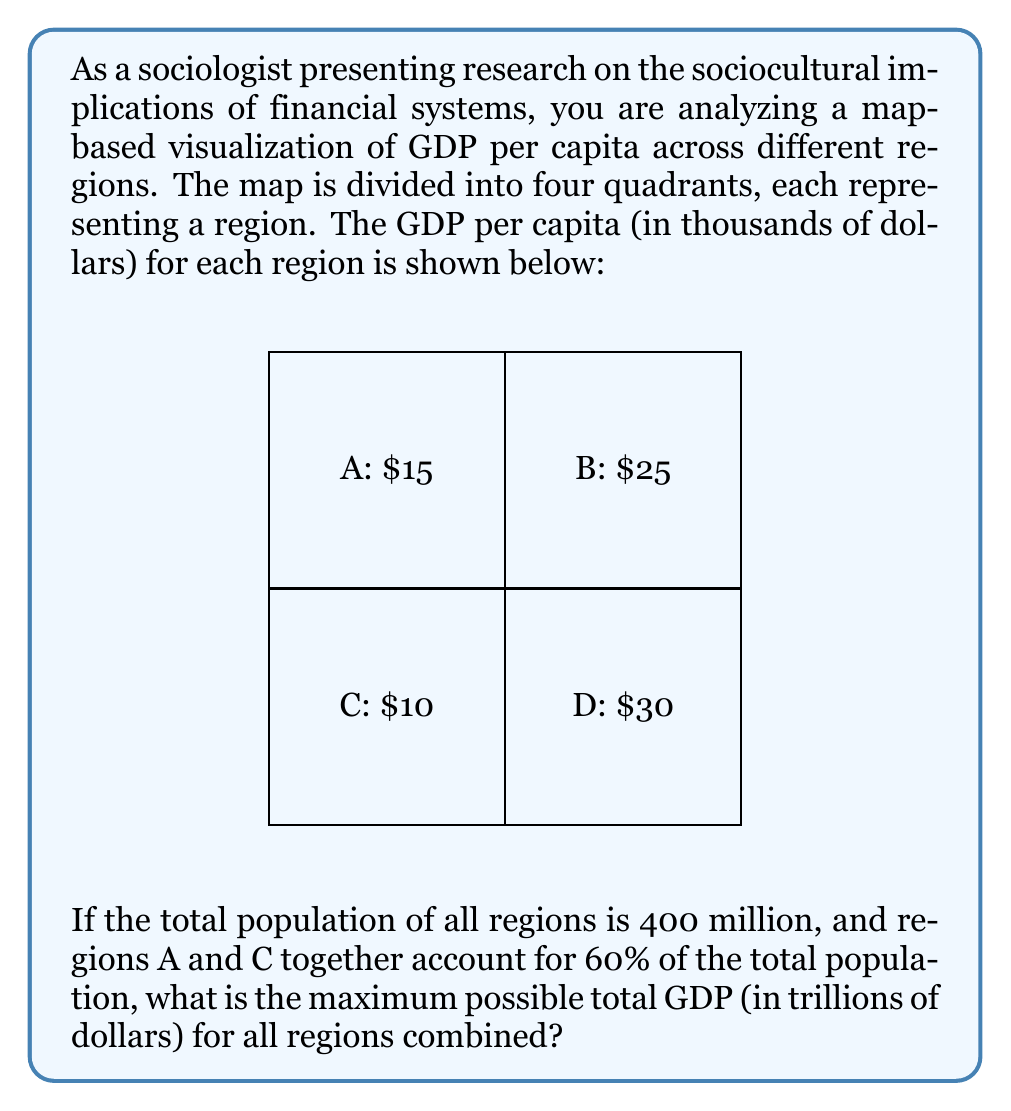Solve this math problem. Let's approach this step-by-step:

1) First, we need to understand what we know:
   - Total population: 400 million
   - Regions A and C together: 60% of total population = 0.6 × 400 million = 240 million
   - GDP per capita for each region (in thousands of dollars): A: $15, B: $25, C: $10, D: $30

2) To maximize the total GDP, we should allocate as much population as possible to the regions with higher GDP per capita.

3) Regions B and D have higher GDP per capita, so we should allocate the remaining 40% of the population to these regions:
   40% of 400 million = 160 million

4) To maximize further, we should put all of this 160 million in region D (highest GDP per capita).

5) For the 240 million in regions A and C, to maximize GDP, we should put as many as possible in A (higher GDP per capita between A and C).

6) So, the population distribution that maximizes total GDP is:
   Region A: 240 million
   Region B: 0
   Region C: 0
   Region D: 160 million

7) Now, let's calculate the GDP for each region:
   Region A: 240 million × $15,000 = $3.6 trillion
   Region B: 0
   Region C: 0
   Region D: 160 million × $30,000 = $4.8 trillion

8) Total maximum GDP = $3.6 trillion + $4.8 trillion = $8.4 trillion

Therefore, the maximum possible total GDP for all regions combined is $8.4 trillion.
Answer: $8.4 trillion 